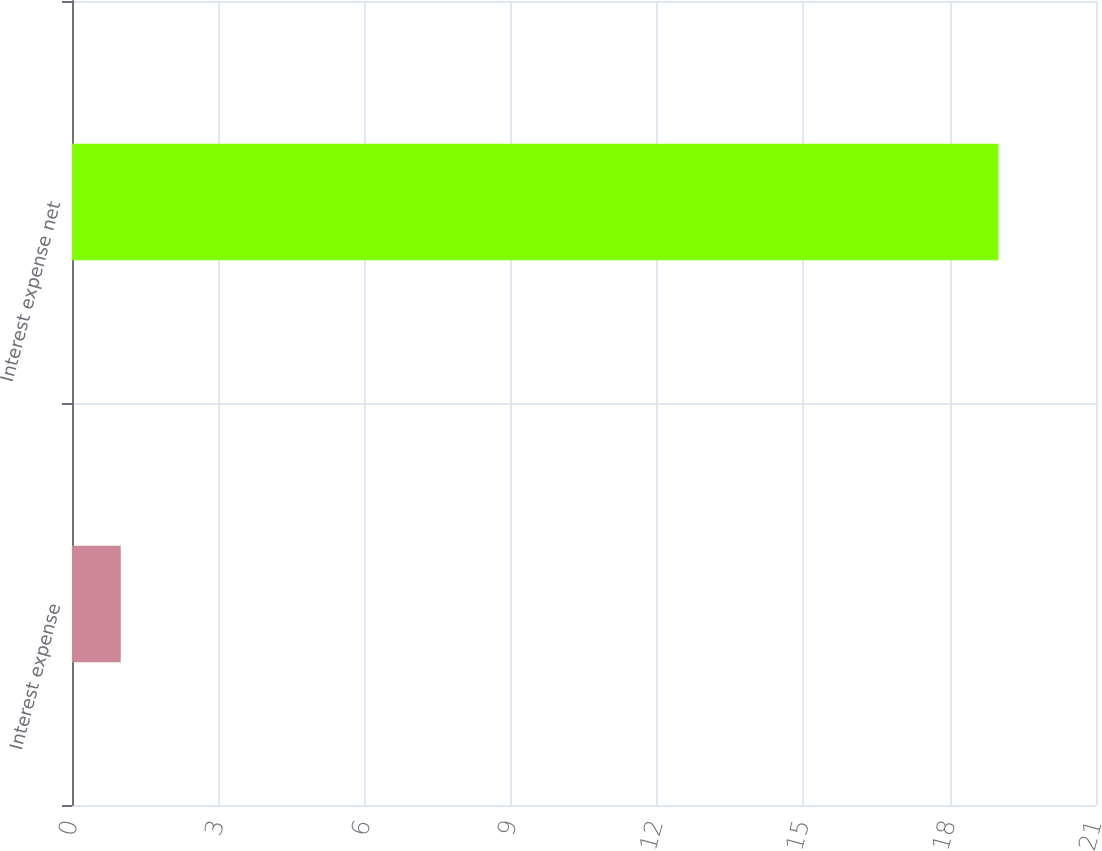Convert chart. <chart><loc_0><loc_0><loc_500><loc_500><bar_chart><fcel>Interest expense<fcel>Interest expense net<nl><fcel>1<fcel>19<nl></chart> 